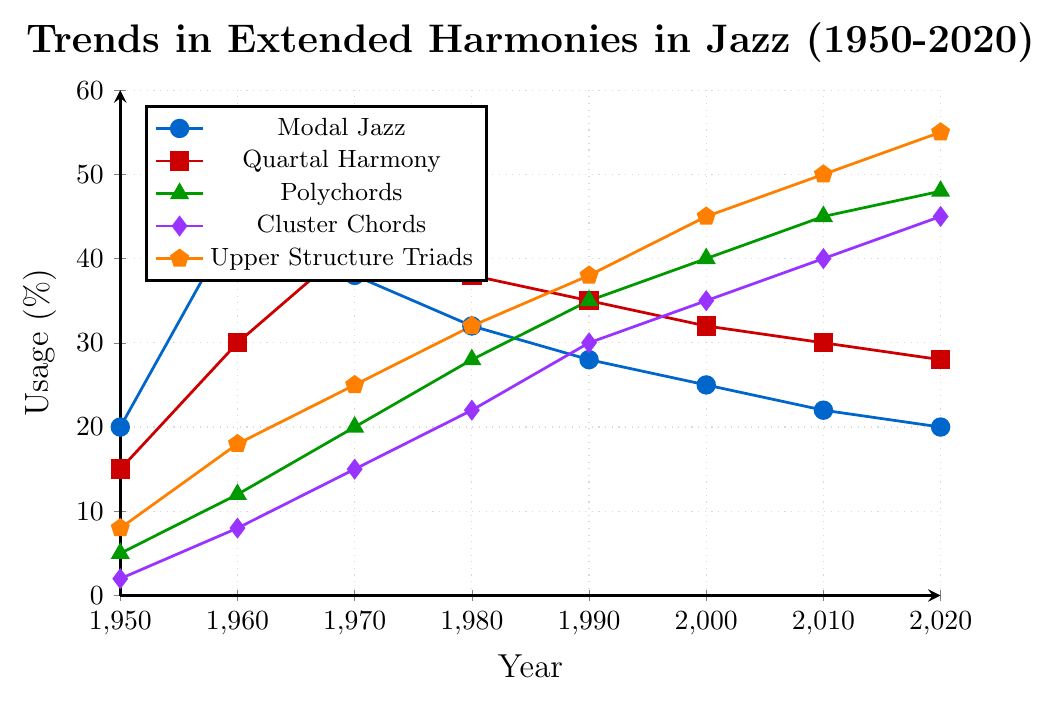What trend do we observe in the usage of Upper Structure Triads from 1950 to 2020? The data shows a steady increase in the usage of Upper Structure Triads from 8% in 1950 to 55% in 2020. This indicates that Upper Structure Triads became more popular over the years.
Answer: A steady increase Which year had the highest usage of Modal Jazz, and what was the percentage? By observing the plotted data for Modal Jazz, the point at the highest position corresponds to the year 1960, with a peak at 45%.
Answer: 1960, 45% In which decade did Polychords see the largest increase in usage percentage, and what was the increment? Comparing the decade increments: 
- 1950 to 1960: 7% 
- 1960 to 1970: 8% 
- 1970 to 1980: 8% 
- 1980 to 1990: 7% 
- 1990 to 2000: 5% 
- 2000 to 2010: 5% 
The largest increase was from 1960 to 1970 and from 1970 to 1980, each with an 8% increment.
Answer: 1960s and 1970s, 8% How does the usage of Quartal Harmony in 1980 compare to its usage in 2020? From the figure, the usage in 1980 was at 38%, while in 2020 it was at 28%. This shows a decrease in the usage of Quartal Harmony over the 40-year span.
Answer: Decreased by 10% Combine the usage percentages of Cluster Chords and Polychords in the year 2000. What is the total percentage? In 2000, the usage of Cluster Chords was 35% and Polychords was 40%. Adding these together: 35% + 40% = 75%.
Answer: 75% What is the general trend in the usage of Cluster Chords from 1950 to 2020? Observing the figure, the usage of Cluster Chords shows a consistent increase from 2% in 1950 to 45% in 2020.
Answer: Consistent increase Which extended harmony had the least change in usage percentage from 1950 to 2020? How much was the change? Comparing the changes in the figure: 
- Modal Jazz: 20% to 20% (no change)
- Quartal Harmony: 15% to 28% (13% change)
- Polychords: 5% to 48% (43% change)
- Cluster Chords: 2% to 45% (43% change)
- Upper Structure Triads: 8% to 55% (47% change)
The least change is in Modal Jazz, remaining at 20%.
Answer: Modal Jazz, no change 